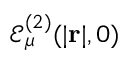<formula> <loc_0><loc_0><loc_500><loc_500>\mathcal { E } _ { \mu } ^ { ( 2 ) } ( | r | , 0 )</formula> 